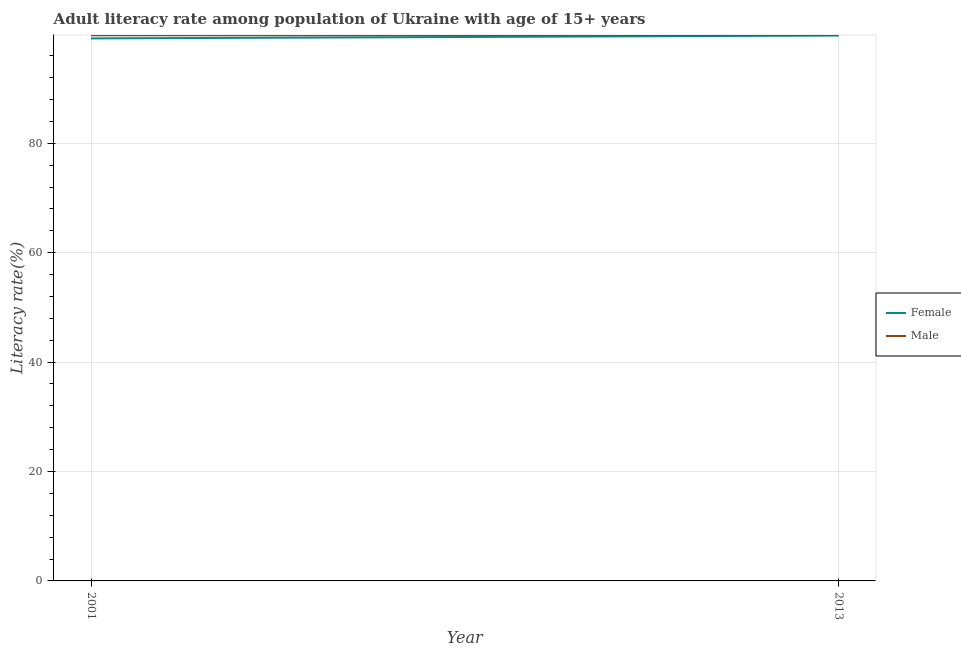How many different coloured lines are there?
Your response must be concise. 2. What is the female adult literacy rate in 2001?
Your answer should be very brief. 99.17. Across all years, what is the maximum male adult literacy rate?
Give a very brief answer. 99.79. Across all years, what is the minimum male adult literacy rate?
Provide a short and direct response. 99.74. What is the total female adult literacy rate in the graph?
Your response must be concise. 198.87. What is the difference between the female adult literacy rate in 2001 and that in 2013?
Provide a short and direct response. -0.53. What is the difference between the female adult literacy rate in 2013 and the male adult literacy rate in 2001?
Ensure brevity in your answer.  -0.04. What is the average female adult literacy rate per year?
Make the answer very short. 99.44. In the year 2001, what is the difference between the female adult literacy rate and male adult literacy rate?
Offer a very short reply. -0.57. What is the ratio of the male adult literacy rate in 2001 to that in 2013?
Your answer should be very brief. 1. Is the female adult literacy rate in 2001 less than that in 2013?
Your answer should be very brief. Yes. In how many years, is the female adult literacy rate greater than the average female adult literacy rate taken over all years?
Provide a succinct answer. 1. Is the male adult literacy rate strictly less than the female adult literacy rate over the years?
Give a very brief answer. No. What is the difference between two consecutive major ticks on the Y-axis?
Offer a very short reply. 20. Are the values on the major ticks of Y-axis written in scientific E-notation?
Offer a very short reply. No. Does the graph contain any zero values?
Ensure brevity in your answer.  No. Where does the legend appear in the graph?
Make the answer very short. Center right. How many legend labels are there?
Give a very brief answer. 2. How are the legend labels stacked?
Offer a terse response. Vertical. What is the title of the graph?
Your response must be concise. Adult literacy rate among population of Ukraine with age of 15+ years. Does "IMF concessional" appear as one of the legend labels in the graph?
Provide a succinct answer. No. What is the label or title of the Y-axis?
Offer a terse response. Literacy rate(%). What is the Literacy rate(%) of Female in 2001?
Provide a succinct answer. 99.17. What is the Literacy rate(%) in Male in 2001?
Keep it short and to the point. 99.74. What is the Literacy rate(%) in Female in 2013?
Offer a very short reply. 99.7. What is the Literacy rate(%) of Male in 2013?
Give a very brief answer. 99.79. Across all years, what is the maximum Literacy rate(%) of Female?
Make the answer very short. 99.7. Across all years, what is the maximum Literacy rate(%) in Male?
Your response must be concise. 99.79. Across all years, what is the minimum Literacy rate(%) in Female?
Your answer should be very brief. 99.17. Across all years, what is the minimum Literacy rate(%) in Male?
Offer a terse response. 99.74. What is the total Literacy rate(%) of Female in the graph?
Give a very brief answer. 198.87. What is the total Literacy rate(%) in Male in the graph?
Your answer should be very brief. 199.53. What is the difference between the Literacy rate(%) of Female in 2001 and that in 2013?
Your answer should be compact. -0.53. What is the difference between the Literacy rate(%) of Male in 2001 and that in 2013?
Ensure brevity in your answer.  -0.05. What is the difference between the Literacy rate(%) of Female in 2001 and the Literacy rate(%) of Male in 2013?
Provide a short and direct response. -0.62. What is the average Literacy rate(%) in Female per year?
Your response must be concise. 99.44. What is the average Literacy rate(%) of Male per year?
Your response must be concise. 99.77. In the year 2001, what is the difference between the Literacy rate(%) in Female and Literacy rate(%) in Male?
Offer a terse response. -0.57. In the year 2013, what is the difference between the Literacy rate(%) of Female and Literacy rate(%) of Male?
Make the answer very short. -0.09. What is the difference between the highest and the second highest Literacy rate(%) of Female?
Make the answer very short. 0.53. What is the difference between the highest and the second highest Literacy rate(%) in Male?
Your answer should be very brief. 0.05. What is the difference between the highest and the lowest Literacy rate(%) in Female?
Provide a succinct answer. 0.53. What is the difference between the highest and the lowest Literacy rate(%) in Male?
Ensure brevity in your answer.  0.05. 